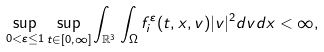<formula> <loc_0><loc_0><loc_500><loc_500>\sup _ { 0 < \varepsilon \leq 1 } \sup _ { t \in [ 0 , \infty ] } \int _ { \mathbb { R } ^ { 3 } } \int _ { \Omega } f _ { i } ^ { \varepsilon } ( t , x , v ) | v | ^ { 2 } d v d x < \infty ,</formula> 